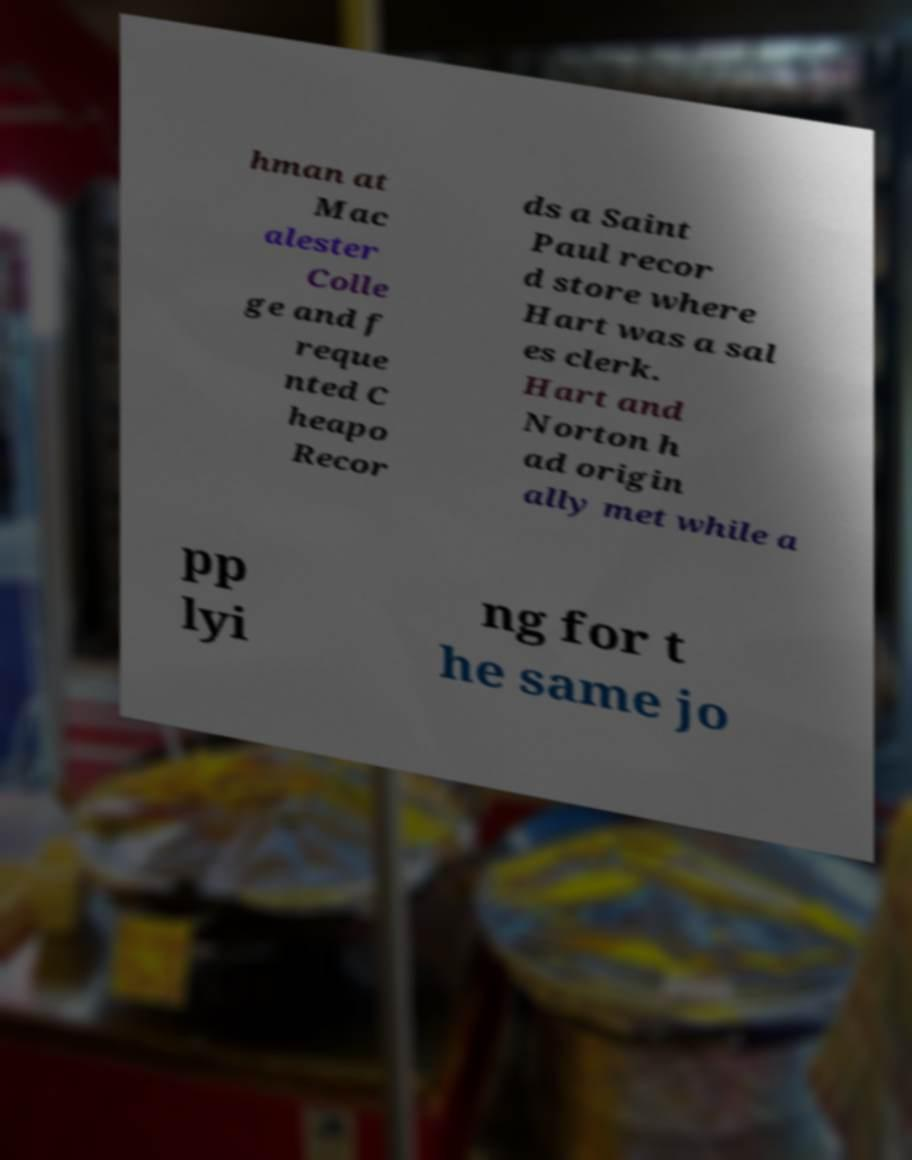For documentation purposes, I need the text within this image transcribed. Could you provide that? hman at Mac alester Colle ge and f reque nted C heapo Recor ds a Saint Paul recor d store where Hart was a sal es clerk. Hart and Norton h ad origin ally met while a pp lyi ng for t he same jo 